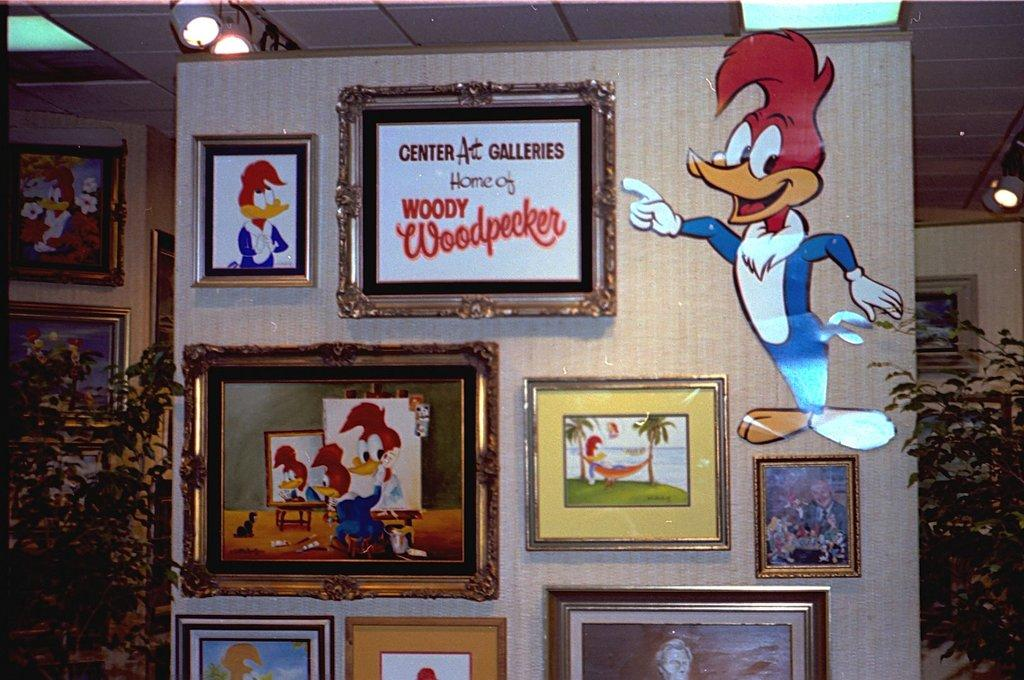What is located in the middle of the image? There is a wall in the middle of the image. What is on the wall? There are frames and posters on the wall. What type of vegetation is present in the image? There are plants in the image. What is visible at the top of the image? There is a roof and lights visible at the top of the image. Can you hear the voice of the person who fell from the roof in the image? There is no person falling from the roof in the image, and therefore no voice to be heard. 